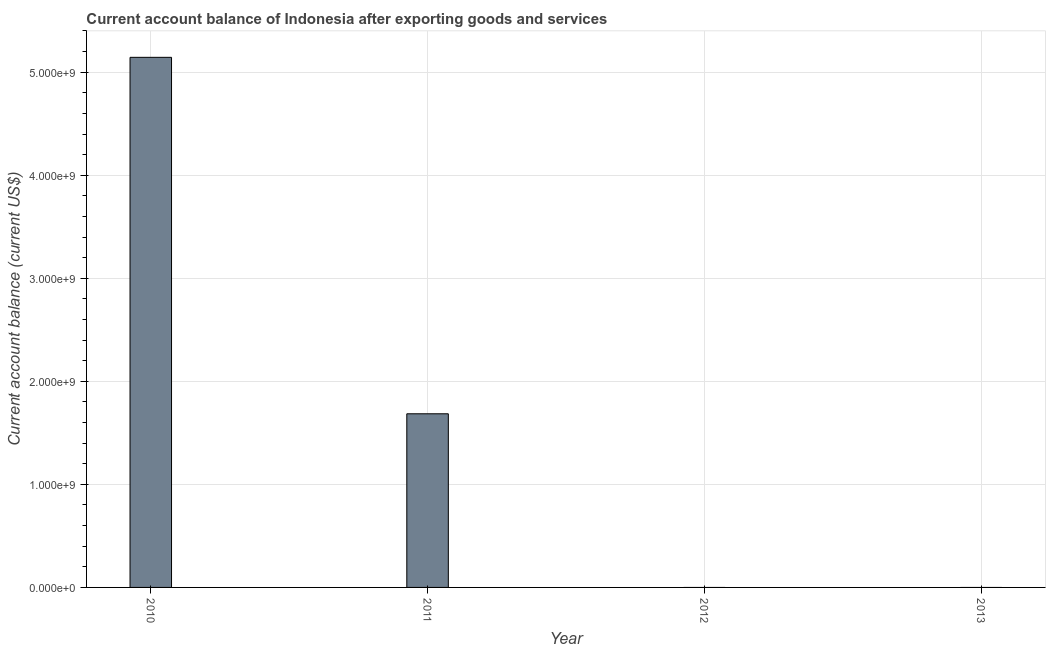Does the graph contain any zero values?
Your answer should be very brief. Yes. Does the graph contain grids?
Provide a succinct answer. Yes. What is the title of the graph?
Provide a short and direct response. Current account balance of Indonesia after exporting goods and services. What is the label or title of the Y-axis?
Ensure brevity in your answer.  Current account balance (current US$). Across all years, what is the maximum current account balance?
Make the answer very short. 5.14e+09. Across all years, what is the minimum current account balance?
Keep it short and to the point. 0. What is the sum of the current account balance?
Your answer should be compact. 6.83e+09. What is the difference between the current account balance in 2010 and 2011?
Your response must be concise. 3.46e+09. What is the average current account balance per year?
Your answer should be very brief. 1.71e+09. What is the median current account balance?
Your response must be concise. 8.43e+08. In how many years, is the current account balance greater than 800000000 US$?
Offer a very short reply. 2. Is the current account balance in 2010 less than that in 2011?
Make the answer very short. No. What is the difference between the highest and the lowest current account balance?
Provide a short and direct response. 5.14e+09. In how many years, is the current account balance greater than the average current account balance taken over all years?
Provide a short and direct response. 1. How many bars are there?
Provide a succinct answer. 2. Are all the bars in the graph horizontal?
Your answer should be very brief. No. What is the Current account balance (current US$) of 2010?
Make the answer very short. 5.14e+09. What is the Current account balance (current US$) of 2011?
Ensure brevity in your answer.  1.69e+09. What is the Current account balance (current US$) of 2013?
Make the answer very short. 0. What is the difference between the Current account balance (current US$) in 2010 and 2011?
Offer a very short reply. 3.46e+09. What is the ratio of the Current account balance (current US$) in 2010 to that in 2011?
Offer a very short reply. 3.05. 